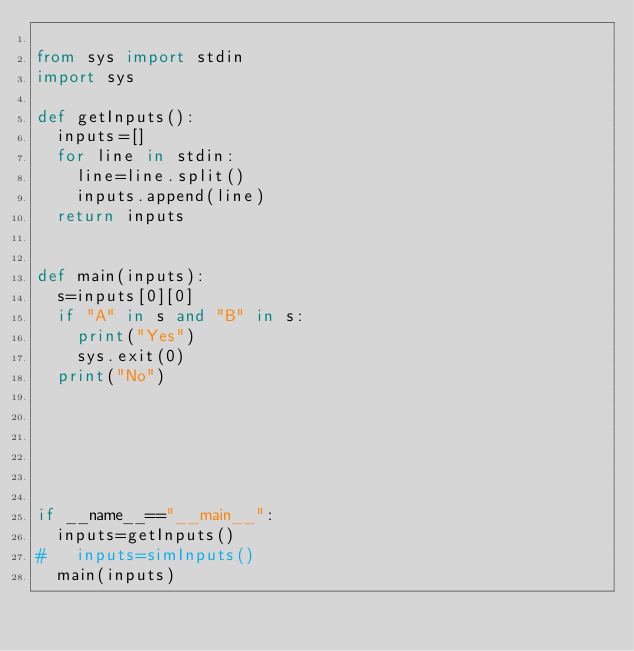Convert code to text. <code><loc_0><loc_0><loc_500><loc_500><_Python_>
from sys import stdin
import sys

def getInputs():
	inputs=[]
	for line in stdin:
		line=line.split()
		inputs.append(line)
	return inputs


def main(inputs):
	s=inputs[0][0]
	if "A" in s and "B" in s:
		print("Yes")
		sys.exit(0)
	print("No")
			
		
	
	
	

if __name__=="__main__":
	inputs=getInputs()
# 	inputs=simInputs()
	main(inputs)
	
</code> 